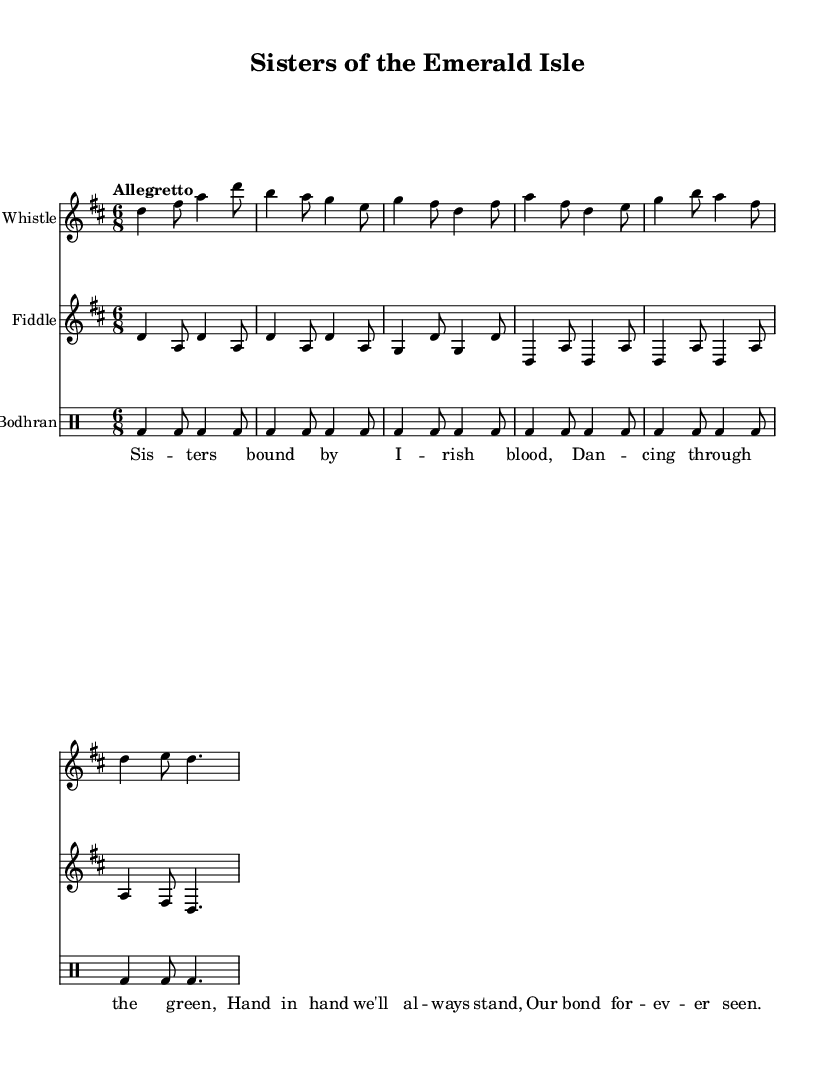What is the key signature of this music? The key signature is indicated by the sharp sign on the staff. In this case, there is an F# present, which signifies the key of D major.
Answer: D major What is the time signature of this music? The time signature is represented by the two numbers at the beginning of the score. The '6' on top and '8' on the bottom indicate that there are six eighth notes in each measure.
Answer: 6/8 What is the tempo marking for this piece? The tempo marking "Allegretto" is written above the staff. This term indicates a moderately fast pace, typically around 98-109 beats per minute.
Answer: Allegretto How many staves are present in the score? By counting the distinct musical staves that are drawn for different instruments, we identify three separate staves: one for the tin whistle, one for the fiddle, and one for the bodhran.
Answer: Three What instrument is the first staff notated for? The first staff clearly has "Tin Whistle" written at the top, which identifies the instrument for the music notated on that staff.
Answer: Tin Whistle Identify the lyrical theme of the song. The lyrics describe a deep bond between sisters celebrating their connection through Irish heritage, which emphasizes themes of togetherness and unity. The repeated reference to "Sisters" and related imagery highlights this theme.
Answer: Sisterhood What is the rhythmic pattern of the bodhran? The rhythm of the bodhran is indicated by consistent patterns of the 'bd' notation across the measures. Each measure comprises alternating quarter and eighth notes, maintaining a driving, steady beat typical in traditional Irish music.
Answer: Steady beat 